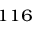Convert formula to latex. <formula><loc_0><loc_0><loc_500><loc_500>^ { 1 1 6 }</formula> 